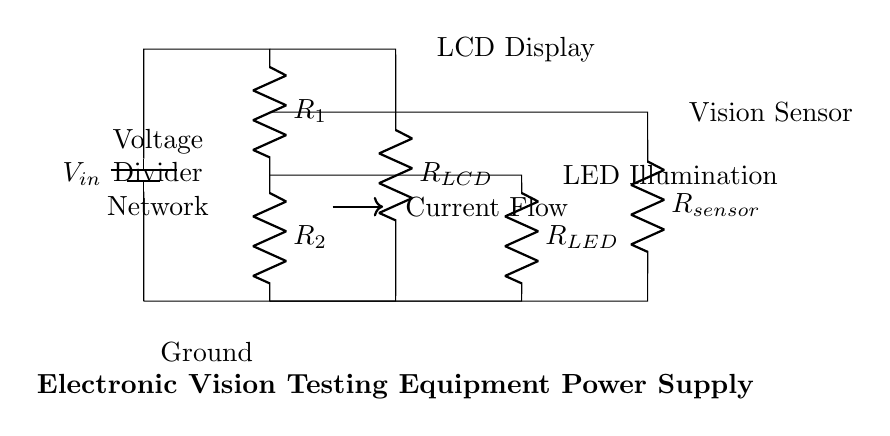What is the input voltage of the circuit? The input voltage is denoted as V_in, which appears at the top left corner of the circuit diagram. It is the voltage supplied to the entire voltage divider network.
Answer: V_in What are the resistances in the voltage divider? The circuit diagram shows three resistances: R_1, R_2, and R_sensor. R_1 and R_2 are part of the main voltage divider, while R_sensor is connected at a higher point.
Answer: R_1, R_2, R_sensor How many loads are powered by the voltage divider? The circuit diagram has three loads connected. These are the LCD display, LED illumination, and the vision sensor, each connected to the voltage divider outputs.
Answer: Three What is the role of R_LCD in the circuit? R_LCD is designated as the load for the LCD display. It connects the output of the voltage divider to power the LCD. This shows it is crucial for proper operation.
Answer: Load for LCD display Which component has the direct current flow indicated in the circuit? The current flow is directly indicated by the arrow pointing to the right, showing it flows through the resistors in the voltage divider network. It highlights the path electric current follows.
Answer: Resistors What is the arrangement of R_1 and R_2 in the voltage divider? R_1 and R_2 are arranged in series, meaning they are connected end-to-end in a single pathway for current flow, allowing for voltage division across them. The current flows through both resistors sequentially.
Answer: Series How does the voltage drop across R_1 and R_2 affect the outputs? The voltage drop across R_1 and R_2 determines the output voltages supplied to the loads (LCD, LED, and sensor). The division of voltage allows each component to receive the appropriate voltage level for operation based on their individual resistance values.
Answer: Determines output voltages 